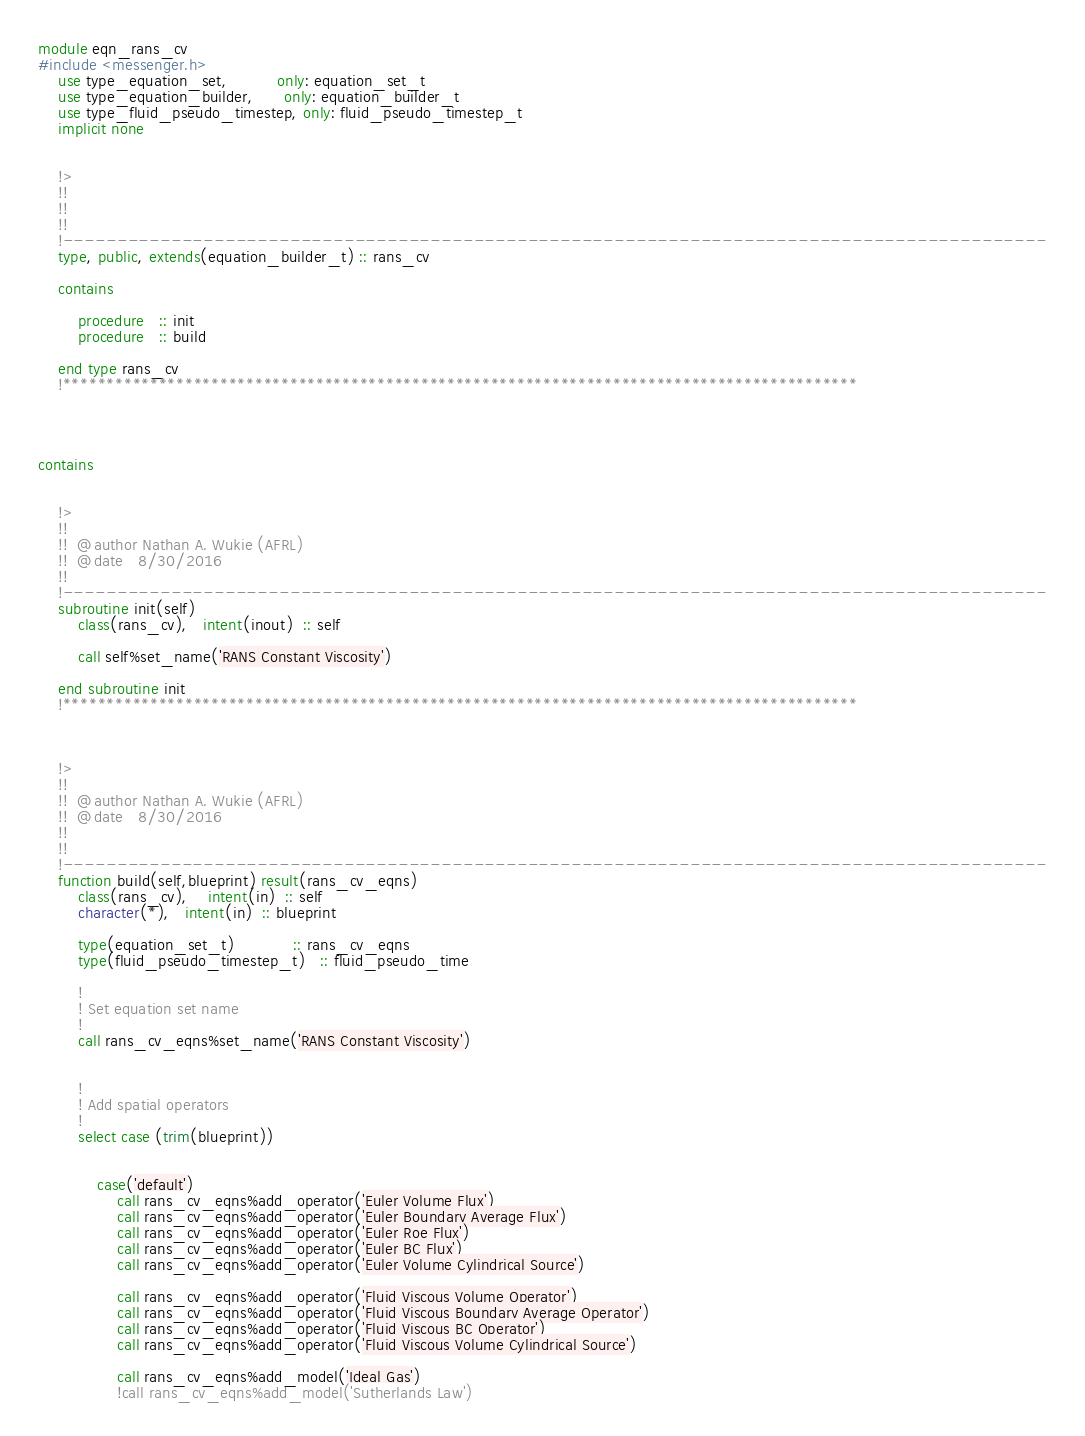Convert code to text. <code><loc_0><loc_0><loc_500><loc_500><_FORTRAN_>module eqn_rans_cv
#include <messenger.h>
    use type_equation_set,          only: equation_set_t
    use type_equation_builder,      only: equation_builder_t
    use type_fluid_pseudo_timestep, only: fluid_pseudo_timestep_t
    implicit none


    !>
    !!
    !!
    !!
    !-------------------------------------------------------------------------------------------
    type, public, extends(equation_builder_t) :: rans_cv

    contains

        procedure   :: init
        procedure   :: build

    end type rans_cv
    !*******************************************************************************************




contains


    !>
    !!
    !!  @author Nathan A. Wukie (AFRL)
    !!  @date   8/30/2016
    !!
    !-------------------------------------------------------------------------------------------
    subroutine init(self)
        class(rans_cv),   intent(inout)  :: self

        call self%set_name('RANS Constant Viscosity')

    end subroutine init
    !*******************************************************************************************



    !>
    !!
    !!  @author Nathan A. Wukie (AFRL)
    !!  @date   8/30/2016
    !!
    !!
    !-------------------------------------------------------------------------------------------
    function build(self,blueprint) result(rans_cv_eqns)
        class(rans_cv),    intent(in)  :: self
        character(*),   intent(in)  :: blueprint

        type(equation_set_t)            :: rans_cv_eqns
        type(fluid_pseudo_timestep_t)   :: fluid_pseudo_time

        !
        ! Set equation set name
        !
        call rans_cv_eqns%set_name('RANS Constant Viscosity')
        

        !
        ! Add spatial operators
        !
        select case (trim(blueprint))


            case('default')
                call rans_cv_eqns%add_operator('Euler Volume Flux')
                call rans_cv_eqns%add_operator('Euler Boundary Average Flux')
                call rans_cv_eqns%add_operator('Euler Roe Flux')
                call rans_cv_eqns%add_operator('Euler BC Flux')
                call rans_cv_eqns%add_operator('Euler Volume Cylindrical Source')

                call rans_cv_eqns%add_operator('Fluid Viscous Volume Operator')
                call rans_cv_eqns%add_operator('Fluid Viscous Boundary Average Operator')
                call rans_cv_eqns%add_operator('Fluid Viscous BC Operator')
                call rans_cv_eqns%add_operator('Fluid Viscous Volume Cylindrical Source')

                call rans_cv_eqns%add_model('Ideal Gas')
                !call rans_cv_eqns%add_model('Sutherlands Law')</code> 